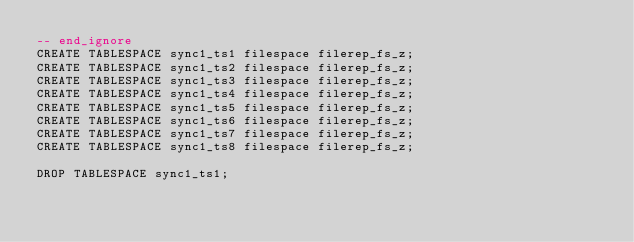<code> <loc_0><loc_0><loc_500><loc_500><_SQL_>-- end_ignore
CREATE TABLESPACE sync1_ts1 filespace filerep_fs_z;
CREATE TABLESPACE sync1_ts2 filespace filerep_fs_z;
CREATE TABLESPACE sync1_ts3 filespace filerep_fs_z;
CREATE TABLESPACE sync1_ts4 filespace filerep_fs_z;
CREATE TABLESPACE sync1_ts5 filespace filerep_fs_z;
CREATE TABLESPACE sync1_ts6 filespace filerep_fs_z;
CREATE TABLESPACE sync1_ts7 filespace filerep_fs_z;
CREATE TABLESPACE sync1_ts8 filespace filerep_fs_z;

DROP TABLESPACE sync1_ts1;

</code> 